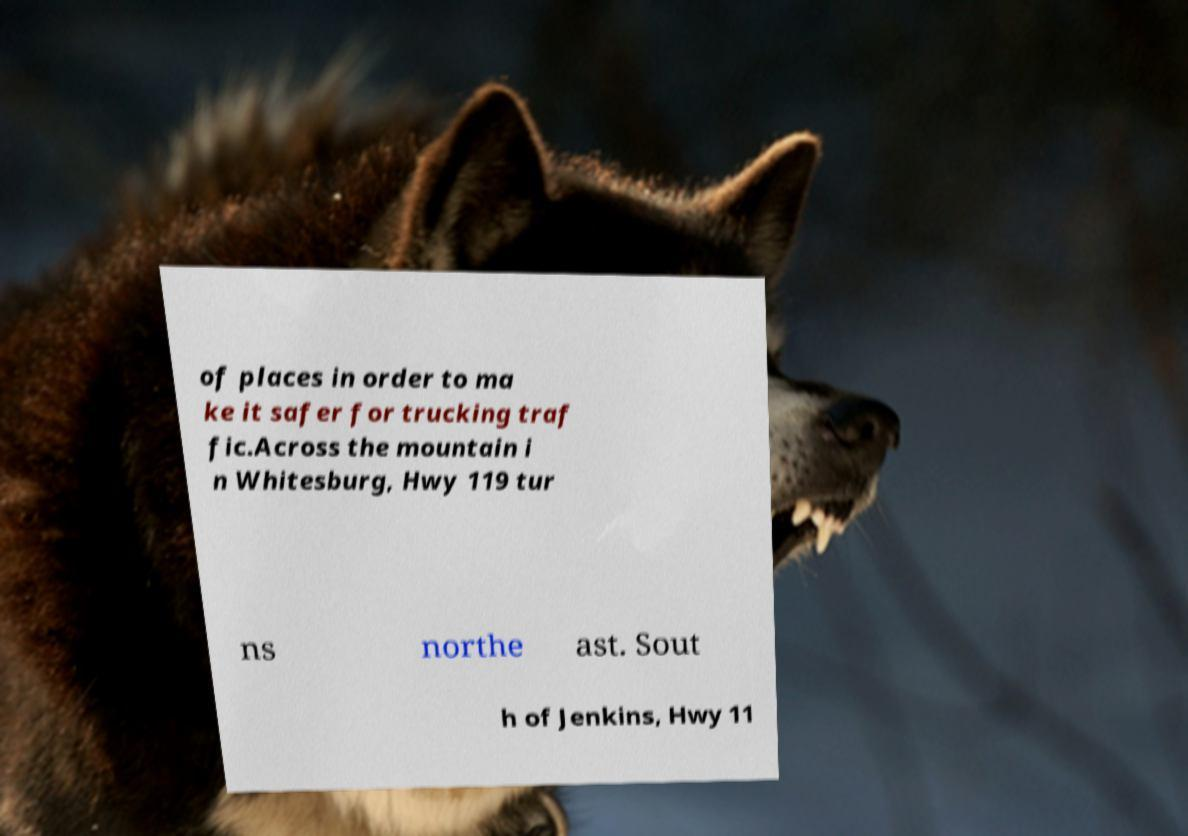I need the written content from this picture converted into text. Can you do that? of places in order to ma ke it safer for trucking traf fic.Across the mountain i n Whitesburg, Hwy 119 tur ns northe ast. Sout h of Jenkins, Hwy 11 